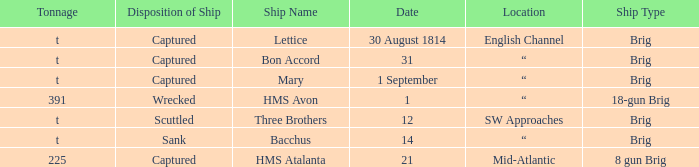What date was a brig type ship located in SW Approaches? 12.0. 